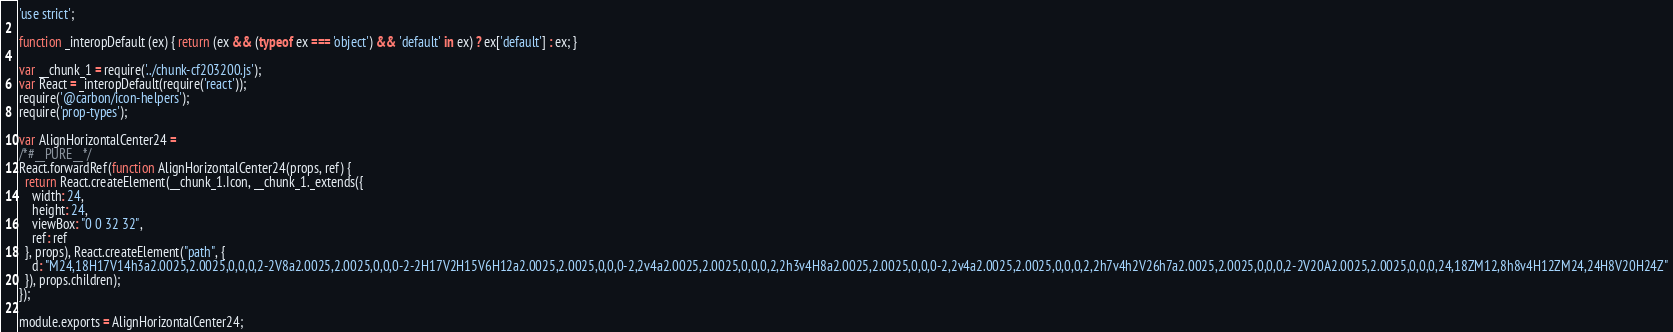Convert code to text. <code><loc_0><loc_0><loc_500><loc_500><_JavaScript_>'use strict';

function _interopDefault (ex) { return (ex && (typeof ex === 'object') && 'default' in ex) ? ex['default'] : ex; }

var __chunk_1 = require('../chunk-cf203200.js');
var React = _interopDefault(require('react'));
require('@carbon/icon-helpers');
require('prop-types');

var AlignHorizontalCenter24 =
/*#__PURE__*/
React.forwardRef(function AlignHorizontalCenter24(props, ref) {
  return React.createElement(__chunk_1.Icon, __chunk_1._extends({
    width: 24,
    height: 24,
    viewBox: "0 0 32 32",
    ref: ref
  }, props), React.createElement("path", {
    d: "M24,18H17V14h3a2.0025,2.0025,0,0,0,2-2V8a2.0025,2.0025,0,0,0-2-2H17V2H15V6H12a2.0025,2.0025,0,0,0-2,2v4a2.0025,2.0025,0,0,0,2,2h3v4H8a2.0025,2.0025,0,0,0-2,2v4a2.0025,2.0025,0,0,0,2,2h7v4h2V26h7a2.0025,2.0025,0,0,0,2-2V20A2.0025,2.0025,0,0,0,24,18ZM12,8h8v4H12ZM24,24H8V20H24Z"
  }), props.children);
});

module.exports = AlignHorizontalCenter24;
</code> 